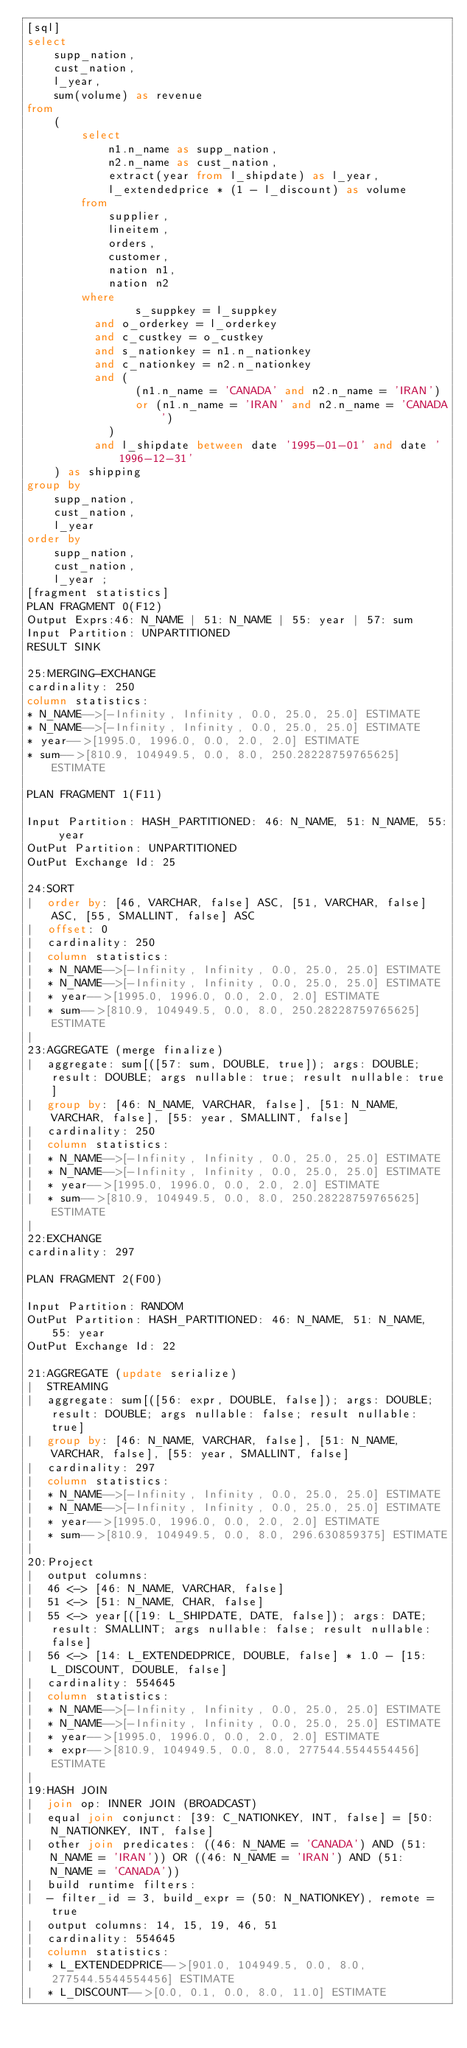Convert code to text. <code><loc_0><loc_0><loc_500><loc_500><_SQL_>[sql]
select
    supp_nation,
    cust_nation,
    l_year,
    sum(volume) as revenue
from
    (
        select
            n1.n_name as supp_nation,
            n2.n_name as cust_nation,
            extract(year from l_shipdate) as l_year,
            l_extendedprice * (1 - l_discount) as volume
        from
            supplier,
            lineitem,
            orders,
            customer,
            nation n1,
            nation n2
        where
                s_suppkey = l_suppkey
          and o_orderkey = l_orderkey
          and c_custkey = o_custkey
          and s_nationkey = n1.n_nationkey
          and c_nationkey = n2.n_nationkey
          and (
                (n1.n_name = 'CANADA' and n2.n_name = 'IRAN')
                or (n1.n_name = 'IRAN' and n2.n_name = 'CANADA')
            )
          and l_shipdate between date '1995-01-01' and date '1996-12-31'
    ) as shipping
group by
    supp_nation,
    cust_nation,
    l_year
order by
    supp_nation,
    cust_nation,
    l_year ;
[fragment statistics]
PLAN FRAGMENT 0(F12)
Output Exprs:46: N_NAME | 51: N_NAME | 55: year | 57: sum
Input Partition: UNPARTITIONED
RESULT SINK

25:MERGING-EXCHANGE
cardinality: 250
column statistics:
* N_NAME-->[-Infinity, Infinity, 0.0, 25.0, 25.0] ESTIMATE
* N_NAME-->[-Infinity, Infinity, 0.0, 25.0, 25.0] ESTIMATE
* year-->[1995.0, 1996.0, 0.0, 2.0, 2.0] ESTIMATE
* sum-->[810.9, 104949.5, 0.0, 8.0, 250.28228759765625] ESTIMATE

PLAN FRAGMENT 1(F11)

Input Partition: HASH_PARTITIONED: 46: N_NAME, 51: N_NAME, 55: year
OutPut Partition: UNPARTITIONED
OutPut Exchange Id: 25

24:SORT
|  order by: [46, VARCHAR, false] ASC, [51, VARCHAR, false] ASC, [55, SMALLINT, false] ASC
|  offset: 0
|  cardinality: 250
|  column statistics:
|  * N_NAME-->[-Infinity, Infinity, 0.0, 25.0, 25.0] ESTIMATE
|  * N_NAME-->[-Infinity, Infinity, 0.0, 25.0, 25.0] ESTIMATE
|  * year-->[1995.0, 1996.0, 0.0, 2.0, 2.0] ESTIMATE
|  * sum-->[810.9, 104949.5, 0.0, 8.0, 250.28228759765625] ESTIMATE
|
23:AGGREGATE (merge finalize)
|  aggregate: sum[([57: sum, DOUBLE, true]); args: DOUBLE; result: DOUBLE; args nullable: true; result nullable: true]
|  group by: [46: N_NAME, VARCHAR, false], [51: N_NAME, VARCHAR, false], [55: year, SMALLINT, false]
|  cardinality: 250
|  column statistics:
|  * N_NAME-->[-Infinity, Infinity, 0.0, 25.0, 25.0] ESTIMATE
|  * N_NAME-->[-Infinity, Infinity, 0.0, 25.0, 25.0] ESTIMATE
|  * year-->[1995.0, 1996.0, 0.0, 2.0, 2.0] ESTIMATE
|  * sum-->[810.9, 104949.5, 0.0, 8.0, 250.28228759765625] ESTIMATE
|
22:EXCHANGE
cardinality: 297

PLAN FRAGMENT 2(F00)

Input Partition: RANDOM
OutPut Partition: HASH_PARTITIONED: 46: N_NAME, 51: N_NAME, 55: year
OutPut Exchange Id: 22

21:AGGREGATE (update serialize)
|  STREAMING
|  aggregate: sum[([56: expr, DOUBLE, false]); args: DOUBLE; result: DOUBLE; args nullable: false; result nullable: true]
|  group by: [46: N_NAME, VARCHAR, false], [51: N_NAME, VARCHAR, false], [55: year, SMALLINT, false]
|  cardinality: 297
|  column statistics:
|  * N_NAME-->[-Infinity, Infinity, 0.0, 25.0, 25.0] ESTIMATE
|  * N_NAME-->[-Infinity, Infinity, 0.0, 25.0, 25.0] ESTIMATE
|  * year-->[1995.0, 1996.0, 0.0, 2.0, 2.0] ESTIMATE
|  * sum-->[810.9, 104949.5, 0.0, 8.0, 296.630859375] ESTIMATE
|
20:Project
|  output columns:
|  46 <-> [46: N_NAME, VARCHAR, false]
|  51 <-> [51: N_NAME, CHAR, false]
|  55 <-> year[([19: L_SHIPDATE, DATE, false]); args: DATE; result: SMALLINT; args nullable: false; result nullable: false]
|  56 <-> [14: L_EXTENDEDPRICE, DOUBLE, false] * 1.0 - [15: L_DISCOUNT, DOUBLE, false]
|  cardinality: 554645
|  column statistics:
|  * N_NAME-->[-Infinity, Infinity, 0.0, 25.0, 25.0] ESTIMATE
|  * N_NAME-->[-Infinity, Infinity, 0.0, 25.0, 25.0] ESTIMATE
|  * year-->[1995.0, 1996.0, 0.0, 2.0, 2.0] ESTIMATE
|  * expr-->[810.9, 104949.5, 0.0, 8.0, 277544.5544554456] ESTIMATE
|
19:HASH JOIN
|  join op: INNER JOIN (BROADCAST)
|  equal join conjunct: [39: C_NATIONKEY, INT, false] = [50: N_NATIONKEY, INT, false]
|  other join predicates: ((46: N_NAME = 'CANADA') AND (51: N_NAME = 'IRAN')) OR ((46: N_NAME = 'IRAN') AND (51: N_NAME = 'CANADA'))
|  build runtime filters:
|  - filter_id = 3, build_expr = (50: N_NATIONKEY), remote = true
|  output columns: 14, 15, 19, 46, 51
|  cardinality: 554645
|  column statistics:
|  * L_EXTENDEDPRICE-->[901.0, 104949.5, 0.0, 8.0, 277544.5544554456] ESTIMATE
|  * L_DISCOUNT-->[0.0, 0.1, 0.0, 8.0, 11.0] ESTIMATE</code> 